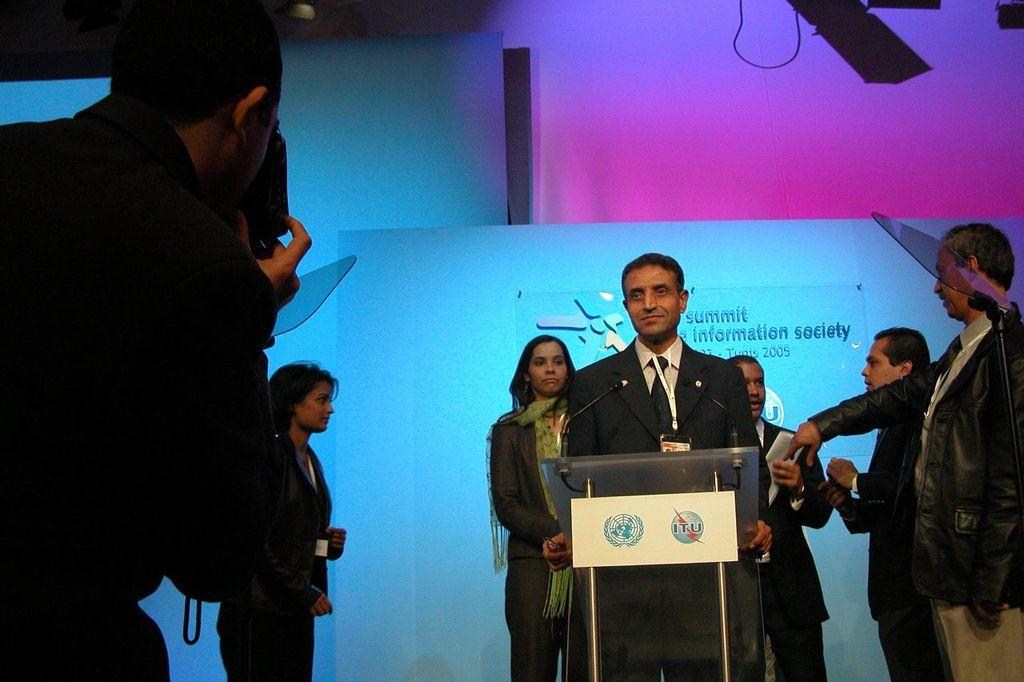Who or what can be seen in the image? There are people in the image. What structure is present in the image? There is a podium in the image. What equipment is visible in the image? There are microphones in the image. Can you describe any other objects in the image? There are unspecified objects in the image. What can be seen in the background of the image? There is a banner in the background of the image. Can you see any carts being used for observation in the image? There are no carts or any observation activity depicted in the image. How many planes are visible in the image? There are no planes present in the image. 